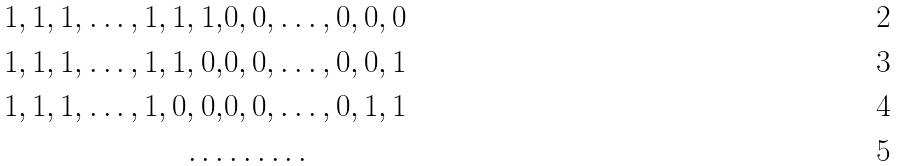Convert formula to latex. <formula><loc_0><loc_0><loc_500><loc_500>1 , 1 , 1 , \dots , 1 , 1 , 1 , & 0 , 0 , \dots , 0 , 0 , 0 \\ 1 , 1 , 1 , \dots , 1 , 1 , 0 , & 0 , 0 , \dots , 0 , 0 , 1 \\ 1 , 1 , 1 , \dots , 1 , 0 , 0 , & 0 , 0 , \dots , 0 , 1 , 1 \\ \dots & \dots \dots</formula> 